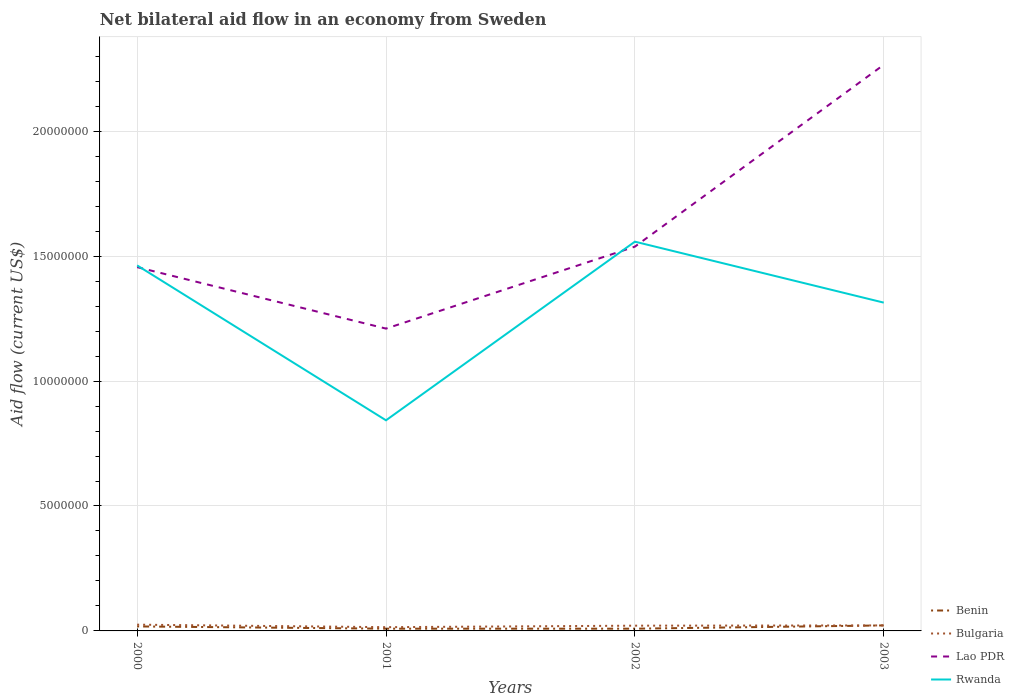How many different coloured lines are there?
Offer a terse response. 4. Does the line corresponding to Rwanda intersect with the line corresponding to Bulgaria?
Make the answer very short. No. Is the number of lines equal to the number of legend labels?
Give a very brief answer. Yes. What is the total net bilateral aid flow in Rwanda in the graph?
Your answer should be very brief. 2.44e+06. What is the difference between the highest and the second highest net bilateral aid flow in Lao PDR?
Provide a succinct answer. 1.06e+07. What is the difference between the highest and the lowest net bilateral aid flow in Rwanda?
Your answer should be very brief. 3. Is the net bilateral aid flow in Benin strictly greater than the net bilateral aid flow in Rwanda over the years?
Your answer should be compact. Yes. How many lines are there?
Your response must be concise. 4. How many years are there in the graph?
Offer a terse response. 4. What is the difference between two consecutive major ticks on the Y-axis?
Give a very brief answer. 5.00e+06. Does the graph contain any zero values?
Your answer should be compact. No. Where does the legend appear in the graph?
Offer a very short reply. Bottom right. What is the title of the graph?
Ensure brevity in your answer.  Net bilateral aid flow in an economy from Sweden. What is the Aid flow (current US$) of Benin in 2000?
Give a very brief answer. 1.80e+05. What is the Aid flow (current US$) in Bulgaria in 2000?
Make the answer very short. 2.50e+05. What is the Aid flow (current US$) of Lao PDR in 2000?
Offer a very short reply. 1.46e+07. What is the Aid flow (current US$) in Rwanda in 2000?
Provide a succinct answer. 1.46e+07. What is the Aid flow (current US$) of Lao PDR in 2001?
Make the answer very short. 1.21e+07. What is the Aid flow (current US$) of Rwanda in 2001?
Offer a terse response. 8.43e+06. What is the Aid flow (current US$) in Benin in 2002?
Keep it short and to the point. 9.00e+04. What is the Aid flow (current US$) of Bulgaria in 2002?
Give a very brief answer. 2.10e+05. What is the Aid flow (current US$) in Lao PDR in 2002?
Give a very brief answer. 1.54e+07. What is the Aid flow (current US$) in Rwanda in 2002?
Make the answer very short. 1.56e+07. What is the Aid flow (current US$) in Benin in 2003?
Your response must be concise. 2.20e+05. What is the Aid flow (current US$) in Lao PDR in 2003?
Your response must be concise. 2.27e+07. What is the Aid flow (current US$) of Rwanda in 2003?
Give a very brief answer. 1.31e+07. Across all years, what is the maximum Aid flow (current US$) in Bulgaria?
Ensure brevity in your answer.  2.50e+05. Across all years, what is the maximum Aid flow (current US$) of Lao PDR?
Make the answer very short. 2.27e+07. Across all years, what is the maximum Aid flow (current US$) in Rwanda?
Ensure brevity in your answer.  1.56e+07. Across all years, what is the minimum Aid flow (current US$) of Benin?
Offer a very short reply. 9.00e+04. Across all years, what is the minimum Aid flow (current US$) of Bulgaria?
Keep it short and to the point. 1.50e+05. Across all years, what is the minimum Aid flow (current US$) in Lao PDR?
Your response must be concise. 1.21e+07. Across all years, what is the minimum Aid flow (current US$) of Rwanda?
Ensure brevity in your answer.  8.43e+06. What is the total Aid flow (current US$) of Benin in the graph?
Give a very brief answer. 5.80e+05. What is the total Aid flow (current US$) of Bulgaria in the graph?
Offer a terse response. 8.30e+05. What is the total Aid flow (current US$) in Lao PDR in the graph?
Make the answer very short. 6.47e+07. What is the total Aid flow (current US$) of Rwanda in the graph?
Offer a very short reply. 5.18e+07. What is the difference between the Aid flow (current US$) of Bulgaria in 2000 and that in 2001?
Keep it short and to the point. 1.00e+05. What is the difference between the Aid flow (current US$) of Lao PDR in 2000 and that in 2001?
Your answer should be very brief. 2.46e+06. What is the difference between the Aid flow (current US$) in Rwanda in 2000 and that in 2001?
Provide a succinct answer. 6.20e+06. What is the difference between the Aid flow (current US$) of Benin in 2000 and that in 2002?
Your response must be concise. 9.00e+04. What is the difference between the Aid flow (current US$) in Bulgaria in 2000 and that in 2002?
Ensure brevity in your answer.  4.00e+04. What is the difference between the Aid flow (current US$) of Lao PDR in 2000 and that in 2002?
Keep it short and to the point. -8.20e+05. What is the difference between the Aid flow (current US$) of Rwanda in 2000 and that in 2002?
Ensure brevity in your answer.  -9.50e+05. What is the difference between the Aid flow (current US$) of Benin in 2000 and that in 2003?
Offer a very short reply. -4.00e+04. What is the difference between the Aid flow (current US$) in Lao PDR in 2000 and that in 2003?
Offer a very short reply. -8.10e+06. What is the difference between the Aid flow (current US$) of Rwanda in 2000 and that in 2003?
Offer a terse response. 1.49e+06. What is the difference between the Aid flow (current US$) of Lao PDR in 2001 and that in 2002?
Ensure brevity in your answer.  -3.28e+06. What is the difference between the Aid flow (current US$) of Rwanda in 2001 and that in 2002?
Provide a succinct answer. -7.15e+06. What is the difference between the Aid flow (current US$) in Benin in 2001 and that in 2003?
Provide a succinct answer. -1.30e+05. What is the difference between the Aid flow (current US$) of Bulgaria in 2001 and that in 2003?
Offer a terse response. -7.00e+04. What is the difference between the Aid flow (current US$) of Lao PDR in 2001 and that in 2003?
Provide a short and direct response. -1.06e+07. What is the difference between the Aid flow (current US$) in Rwanda in 2001 and that in 2003?
Offer a very short reply. -4.71e+06. What is the difference between the Aid flow (current US$) of Benin in 2002 and that in 2003?
Give a very brief answer. -1.30e+05. What is the difference between the Aid flow (current US$) in Lao PDR in 2002 and that in 2003?
Offer a terse response. -7.28e+06. What is the difference between the Aid flow (current US$) of Rwanda in 2002 and that in 2003?
Your response must be concise. 2.44e+06. What is the difference between the Aid flow (current US$) of Benin in 2000 and the Aid flow (current US$) of Bulgaria in 2001?
Give a very brief answer. 3.00e+04. What is the difference between the Aid flow (current US$) of Benin in 2000 and the Aid flow (current US$) of Lao PDR in 2001?
Offer a terse response. -1.19e+07. What is the difference between the Aid flow (current US$) of Benin in 2000 and the Aid flow (current US$) of Rwanda in 2001?
Your answer should be compact. -8.25e+06. What is the difference between the Aid flow (current US$) in Bulgaria in 2000 and the Aid flow (current US$) in Lao PDR in 2001?
Keep it short and to the point. -1.18e+07. What is the difference between the Aid flow (current US$) in Bulgaria in 2000 and the Aid flow (current US$) in Rwanda in 2001?
Offer a terse response. -8.18e+06. What is the difference between the Aid flow (current US$) of Lao PDR in 2000 and the Aid flow (current US$) of Rwanda in 2001?
Provide a short and direct response. 6.13e+06. What is the difference between the Aid flow (current US$) of Benin in 2000 and the Aid flow (current US$) of Bulgaria in 2002?
Keep it short and to the point. -3.00e+04. What is the difference between the Aid flow (current US$) in Benin in 2000 and the Aid flow (current US$) in Lao PDR in 2002?
Your response must be concise. -1.52e+07. What is the difference between the Aid flow (current US$) in Benin in 2000 and the Aid flow (current US$) in Rwanda in 2002?
Provide a succinct answer. -1.54e+07. What is the difference between the Aid flow (current US$) of Bulgaria in 2000 and the Aid flow (current US$) of Lao PDR in 2002?
Your response must be concise. -1.51e+07. What is the difference between the Aid flow (current US$) of Bulgaria in 2000 and the Aid flow (current US$) of Rwanda in 2002?
Ensure brevity in your answer.  -1.53e+07. What is the difference between the Aid flow (current US$) of Lao PDR in 2000 and the Aid flow (current US$) of Rwanda in 2002?
Offer a terse response. -1.02e+06. What is the difference between the Aid flow (current US$) in Benin in 2000 and the Aid flow (current US$) in Lao PDR in 2003?
Your answer should be compact. -2.25e+07. What is the difference between the Aid flow (current US$) of Benin in 2000 and the Aid flow (current US$) of Rwanda in 2003?
Offer a terse response. -1.30e+07. What is the difference between the Aid flow (current US$) of Bulgaria in 2000 and the Aid flow (current US$) of Lao PDR in 2003?
Offer a terse response. -2.24e+07. What is the difference between the Aid flow (current US$) in Bulgaria in 2000 and the Aid flow (current US$) in Rwanda in 2003?
Your answer should be compact. -1.29e+07. What is the difference between the Aid flow (current US$) of Lao PDR in 2000 and the Aid flow (current US$) of Rwanda in 2003?
Your answer should be very brief. 1.42e+06. What is the difference between the Aid flow (current US$) of Benin in 2001 and the Aid flow (current US$) of Lao PDR in 2002?
Your answer should be very brief. -1.53e+07. What is the difference between the Aid flow (current US$) in Benin in 2001 and the Aid flow (current US$) in Rwanda in 2002?
Provide a succinct answer. -1.55e+07. What is the difference between the Aid flow (current US$) of Bulgaria in 2001 and the Aid flow (current US$) of Lao PDR in 2002?
Provide a short and direct response. -1.52e+07. What is the difference between the Aid flow (current US$) of Bulgaria in 2001 and the Aid flow (current US$) of Rwanda in 2002?
Provide a short and direct response. -1.54e+07. What is the difference between the Aid flow (current US$) of Lao PDR in 2001 and the Aid flow (current US$) of Rwanda in 2002?
Your response must be concise. -3.48e+06. What is the difference between the Aid flow (current US$) of Benin in 2001 and the Aid flow (current US$) of Bulgaria in 2003?
Your response must be concise. -1.30e+05. What is the difference between the Aid flow (current US$) of Benin in 2001 and the Aid flow (current US$) of Lao PDR in 2003?
Your answer should be compact. -2.26e+07. What is the difference between the Aid flow (current US$) in Benin in 2001 and the Aid flow (current US$) in Rwanda in 2003?
Provide a succinct answer. -1.30e+07. What is the difference between the Aid flow (current US$) in Bulgaria in 2001 and the Aid flow (current US$) in Lao PDR in 2003?
Keep it short and to the point. -2.25e+07. What is the difference between the Aid flow (current US$) of Bulgaria in 2001 and the Aid flow (current US$) of Rwanda in 2003?
Keep it short and to the point. -1.30e+07. What is the difference between the Aid flow (current US$) of Lao PDR in 2001 and the Aid flow (current US$) of Rwanda in 2003?
Ensure brevity in your answer.  -1.04e+06. What is the difference between the Aid flow (current US$) of Benin in 2002 and the Aid flow (current US$) of Bulgaria in 2003?
Offer a very short reply. -1.30e+05. What is the difference between the Aid flow (current US$) of Benin in 2002 and the Aid flow (current US$) of Lao PDR in 2003?
Keep it short and to the point. -2.26e+07. What is the difference between the Aid flow (current US$) of Benin in 2002 and the Aid flow (current US$) of Rwanda in 2003?
Give a very brief answer. -1.30e+07. What is the difference between the Aid flow (current US$) in Bulgaria in 2002 and the Aid flow (current US$) in Lao PDR in 2003?
Keep it short and to the point. -2.24e+07. What is the difference between the Aid flow (current US$) of Bulgaria in 2002 and the Aid flow (current US$) of Rwanda in 2003?
Your answer should be compact. -1.29e+07. What is the difference between the Aid flow (current US$) in Lao PDR in 2002 and the Aid flow (current US$) in Rwanda in 2003?
Make the answer very short. 2.24e+06. What is the average Aid flow (current US$) of Benin per year?
Offer a terse response. 1.45e+05. What is the average Aid flow (current US$) of Bulgaria per year?
Provide a succinct answer. 2.08e+05. What is the average Aid flow (current US$) of Lao PDR per year?
Your answer should be very brief. 1.62e+07. What is the average Aid flow (current US$) in Rwanda per year?
Provide a succinct answer. 1.29e+07. In the year 2000, what is the difference between the Aid flow (current US$) of Benin and Aid flow (current US$) of Bulgaria?
Keep it short and to the point. -7.00e+04. In the year 2000, what is the difference between the Aid flow (current US$) in Benin and Aid flow (current US$) in Lao PDR?
Offer a terse response. -1.44e+07. In the year 2000, what is the difference between the Aid flow (current US$) of Benin and Aid flow (current US$) of Rwanda?
Provide a succinct answer. -1.44e+07. In the year 2000, what is the difference between the Aid flow (current US$) in Bulgaria and Aid flow (current US$) in Lao PDR?
Your answer should be compact. -1.43e+07. In the year 2000, what is the difference between the Aid flow (current US$) of Bulgaria and Aid flow (current US$) of Rwanda?
Offer a very short reply. -1.44e+07. In the year 2000, what is the difference between the Aid flow (current US$) in Lao PDR and Aid flow (current US$) in Rwanda?
Keep it short and to the point. -7.00e+04. In the year 2001, what is the difference between the Aid flow (current US$) in Benin and Aid flow (current US$) in Bulgaria?
Make the answer very short. -6.00e+04. In the year 2001, what is the difference between the Aid flow (current US$) in Benin and Aid flow (current US$) in Lao PDR?
Your response must be concise. -1.20e+07. In the year 2001, what is the difference between the Aid flow (current US$) in Benin and Aid flow (current US$) in Rwanda?
Offer a terse response. -8.34e+06. In the year 2001, what is the difference between the Aid flow (current US$) of Bulgaria and Aid flow (current US$) of Lao PDR?
Provide a succinct answer. -1.20e+07. In the year 2001, what is the difference between the Aid flow (current US$) of Bulgaria and Aid flow (current US$) of Rwanda?
Your response must be concise. -8.28e+06. In the year 2001, what is the difference between the Aid flow (current US$) of Lao PDR and Aid flow (current US$) of Rwanda?
Provide a short and direct response. 3.67e+06. In the year 2002, what is the difference between the Aid flow (current US$) in Benin and Aid flow (current US$) in Lao PDR?
Ensure brevity in your answer.  -1.53e+07. In the year 2002, what is the difference between the Aid flow (current US$) of Benin and Aid flow (current US$) of Rwanda?
Make the answer very short. -1.55e+07. In the year 2002, what is the difference between the Aid flow (current US$) in Bulgaria and Aid flow (current US$) in Lao PDR?
Your response must be concise. -1.52e+07. In the year 2002, what is the difference between the Aid flow (current US$) of Bulgaria and Aid flow (current US$) of Rwanda?
Offer a very short reply. -1.54e+07. In the year 2002, what is the difference between the Aid flow (current US$) in Lao PDR and Aid flow (current US$) in Rwanda?
Keep it short and to the point. -2.00e+05. In the year 2003, what is the difference between the Aid flow (current US$) of Benin and Aid flow (current US$) of Lao PDR?
Provide a succinct answer. -2.24e+07. In the year 2003, what is the difference between the Aid flow (current US$) in Benin and Aid flow (current US$) in Rwanda?
Your answer should be compact. -1.29e+07. In the year 2003, what is the difference between the Aid flow (current US$) in Bulgaria and Aid flow (current US$) in Lao PDR?
Ensure brevity in your answer.  -2.24e+07. In the year 2003, what is the difference between the Aid flow (current US$) in Bulgaria and Aid flow (current US$) in Rwanda?
Your answer should be very brief. -1.29e+07. In the year 2003, what is the difference between the Aid flow (current US$) of Lao PDR and Aid flow (current US$) of Rwanda?
Keep it short and to the point. 9.52e+06. What is the ratio of the Aid flow (current US$) of Benin in 2000 to that in 2001?
Your response must be concise. 2. What is the ratio of the Aid flow (current US$) of Bulgaria in 2000 to that in 2001?
Offer a terse response. 1.67. What is the ratio of the Aid flow (current US$) of Lao PDR in 2000 to that in 2001?
Give a very brief answer. 1.2. What is the ratio of the Aid flow (current US$) in Rwanda in 2000 to that in 2001?
Your answer should be compact. 1.74. What is the ratio of the Aid flow (current US$) of Bulgaria in 2000 to that in 2002?
Make the answer very short. 1.19. What is the ratio of the Aid flow (current US$) of Lao PDR in 2000 to that in 2002?
Your response must be concise. 0.95. What is the ratio of the Aid flow (current US$) of Rwanda in 2000 to that in 2002?
Keep it short and to the point. 0.94. What is the ratio of the Aid flow (current US$) of Benin in 2000 to that in 2003?
Offer a terse response. 0.82. What is the ratio of the Aid flow (current US$) of Bulgaria in 2000 to that in 2003?
Offer a very short reply. 1.14. What is the ratio of the Aid flow (current US$) in Lao PDR in 2000 to that in 2003?
Provide a succinct answer. 0.64. What is the ratio of the Aid flow (current US$) in Rwanda in 2000 to that in 2003?
Provide a short and direct response. 1.11. What is the ratio of the Aid flow (current US$) of Lao PDR in 2001 to that in 2002?
Provide a succinct answer. 0.79. What is the ratio of the Aid flow (current US$) of Rwanda in 2001 to that in 2002?
Ensure brevity in your answer.  0.54. What is the ratio of the Aid flow (current US$) of Benin in 2001 to that in 2003?
Your answer should be compact. 0.41. What is the ratio of the Aid flow (current US$) in Bulgaria in 2001 to that in 2003?
Make the answer very short. 0.68. What is the ratio of the Aid flow (current US$) of Lao PDR in 2001 to that in 2003?
Your response must be concise. 0.53. What is the ratio of the Aid flow (current US$) in Rwanda in 2001 to that in 2003?
Make the answer very short. 0.64. What is the ratio of the Aid flow (current US$) in Benin in 2002 to that in 2003?
Ensure brevity in your answer.  0.41. What is the ratio of the Aid flow (current US$) of Bulgaria in 2002 to that in 2003?
Offer a very short reply. 0.95. What is the ratio of the Aid flow (current US$) of Lao PDR in 2002 to that in 2003?
Make the answer very short. 0.68. What is the ratio of the Aid flow (current US$) of Rwanda in 2002 to that in 2003?
Your response must be concise. 1.19. What is the difference between the highest and the second highest Aid flow (current US$) of Benin?
Your response must be concise. 4.00e+04. What is the difference between the highest and the second highest Aid flow (current US$) of Lao PDR?
Provide a succinct answer. 7.28e+06. What is the difference between the highest and the second highest Aid flow (current US$) in Rwanda?
Your answer should be compact. 9.50e+05. What is the difference between the highest and the lowest Aid flow (current US$) of Benin?
Make the answer very short. 1.30e+05. What is the difference between the highest and the lowest Aid flow (current US$) of Bulgaria?
Offer a terse response. 1.00e+05. What is the difference between the highest and the lowest Aid flow (current US$) of Lao PDR?
Provide a succinct answer. 1.06e+07. What is the difference between the highest and the lowest Aid flow (current US$) of Rwanda?
Offer a very short reply. 7.15e+06. 